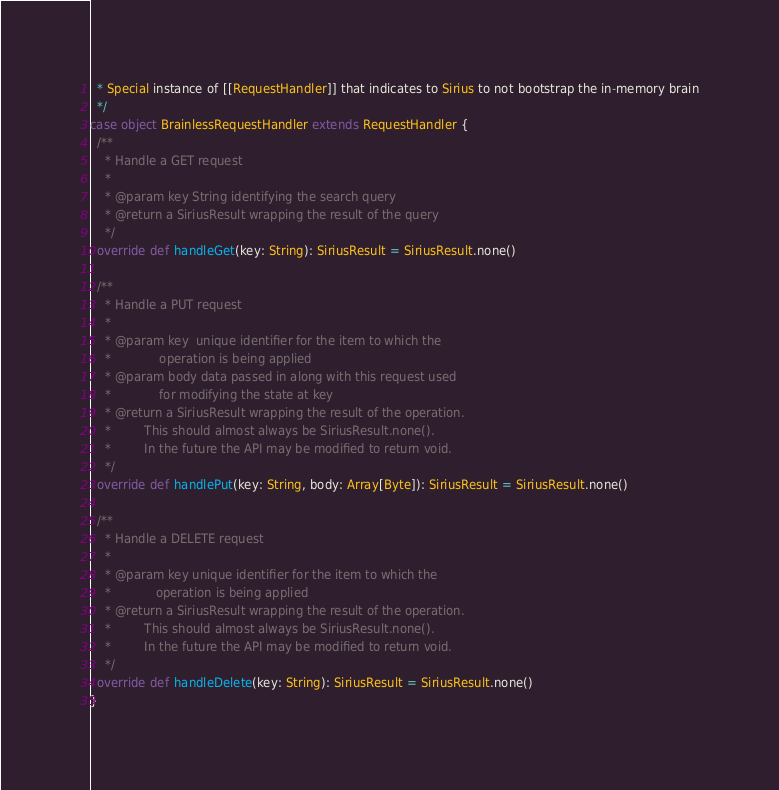<code> <loc_0><loc_0><loc_500><loc_500><_Scala_>  * Special instance of [[RequestHandler]] that indicates to Sirius to not bootstrap the in-memory brain
  */
case object BrainlessRequestHandler extends RequestHandler {
  /**
    * Handle a GET request
    *
    * @param key String identifying the search query
    * @return a SiriusResult wrapping the result of the query
    */
  override def handleGet(key: String): SiriusResult = SiriusResult.none()

  /**
    * Handle a PUT request
    *
    * @param key  unique identifier for the item to which the
    *             operation is being applied
    * @param body data passed in along with this request used
    *             for modifying the state at key
    * @return a SiriusResult wrapping the result of the operation.
    *         This should almost always be SiriusResult.none().
    *         In the future the API may be modified to return void.
    */
  override def handlePut(key: String, body: Array[Byte]): SiriusResult = SiriusResult.none()

  /**
    * Handle a DELETE request
    *
    * @param key unique identifier for the item to which the
    *            operation is being applied
    * @return a SiriusResult wrapping the result of the operation.
    *         This should almost always be SiriusResult.none().
    *         In the future the API may be modified to return void.
    */
  override def handleDelete(key: String): SiriusResult = SiriusResult.none()
}
</code> 